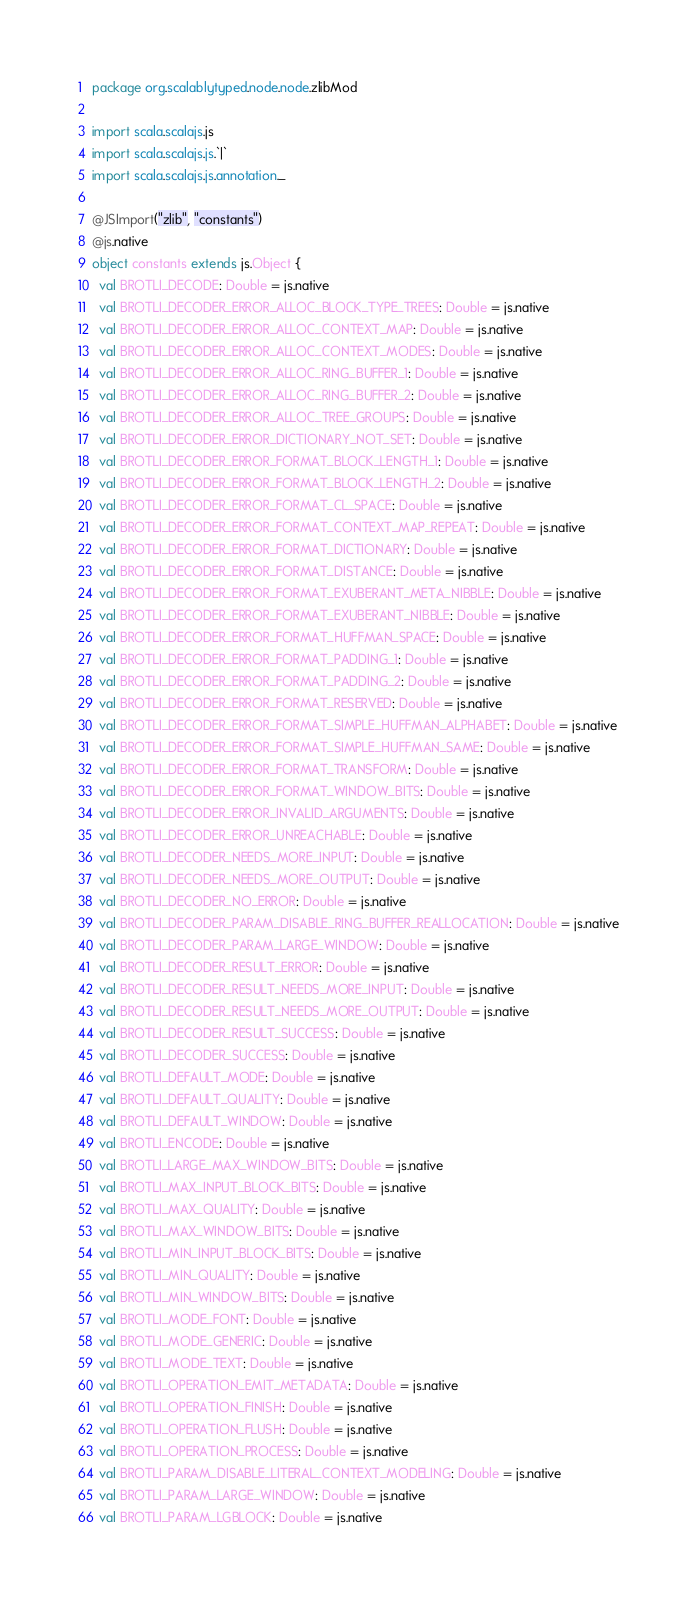Convert code to text. <code><loc_0><loc_0><loc_500><loc_500><_Scala_>package org.scalablytyped.node.node.zlibMod

import scala.scalajs.js
import scala.scalajs.js.`|`
import scala.scalajs.js.annotation._

@JSImport("zlib", "constants")
@js.native
object constants extends js.Object {
  val BROTLI_DECODE: Double = js.native
  val BROTLI_DECODER_ERROR_ALLOC_BLOCK_TYPE_TREES: Double = js.native
  val BROTLI_DECODER_ERROR_ALLOC_CONTEXT_MAP: Double = js.native
  val BROTLI_DECODER_ERROR_ALLOC_CONTEXT_MODES: Double = js.native
  val BROTLI_DECODER_ERROR_ALLOC_RING_BUFFER_1: Double = js.native
  val BROTLI_DECODER_ERROR_ALLOC_RING_BUFFER_2: Double = js.native
  val BROTLI_DECODER_ERROR_ALLOC_TREE_GROUPS: Double = js.native
  val BROTLI_DECODER_ERROR_DICTIONARY_NOT_SET: Double = js.native
  val BROTLI_DECODER_ERROR_FORMAT_BLOCK_LENGTH_1: Double = js.native
  val BROTLI_DECODER_ERROR_FORMAT_BLOCK_LENGTH_2: Double = js.native
  val BROTLI_DECODER_ERROR_FORMAT_CL_SPACE: Double = js.native
  val BROTLI_DECODER_ERROR_FORMAT_CONTEXT_MAP_REPEAT: Double = js.native
  val BROTLI_DECODER_ERROR_FORMAT_DICTIONARY: Double = js.native
  val BROTLI_DECODER_ERROR_FORMAT_DISTANCE: Double = js.native
  val BROTLI_DECODER_ERROR_FORMAT_EXUBERANT_META_NIBBLE: Double = js.native
  val BROTLI_DECODER_ERROR_FORMAT_EXUBERANT_NIBBLE: Double = js.native
  val BROTLI_DECODER_ERROR_FORMAT_HUFFMAN_SPACE: Double = js.native
  val BROTLI_DECODER_ERROR_FORMAT_PADDING_1: Double = js.native
  val BROTLI_DECODER_ERROR_FORMAT_PADDING_2: Double = js.native
  val BROTLI_DECODER_ERROR_FORMAT_RESERVED: Double = js.native
  val BROTLI_DECODER_ERROR_FORMAT_SIMPLE_HUFFMAN_ALPHABET: Double = js.native
  val BROTLI_DECODER_ERROR_FORMAT_SIMPLE_HUFFMAN_SAME: Double = js.native
  val BROTLI_DECODER_ERROR_FORMAT_TRANSFORM: Double = js.native
  val BROTLI_DECODER_ERROR_FORMAT_WINDOW_BITS: Double = js.native
  val BROTLI_DECODER_ERROR_INVALID_ARGUMENTS: Double = js.native
  val BROTLI_DECODER_ERROR_UNREACHABLE: Double = js.native
  val BROTLI_DECODER_NEEDS_MORE_INPUT: Double = js.native
  val BROTLI_DECODER_NEEDS_MORE_OUTPUT: Double = js.native
  val BROTLI_DECODER_NO_ERROR: Double = js.native
  val BROTLI_DECODER_PARAM_DISABLE_RING_BUFFER_REALLOCATION: Double = js.native
  val BROTLI_DECODER_PARAM_LARGE_WINDOW: Double = js.native
  val BROTLI_DECODER_RESULT_ERROR: Double = js.native
  val BROTLI_DECODER_RESULT_NEEDS_MORE_INPUT: Double = js.native
  val BROTLI_DECODER_RESULT_NEEDS_MORE_OUTPUT: Double = js.native
  val BROTLI_DECODER_RESULT_SUCCESS: Double = js.native
  val BROTLI_DECODER_SUCCESS: Double = js.native
  val BROTLI_DEFAULT_MODE: Double = js.native
  val BROTLI_DEFAULT_QUALITY: Double = js.native
  val BROTLI_DEFAULT_WINDOW: Double = js.native
  val BROTLI_ENCODE: Double = js.native
  val BROTLI_LARGE_MAX_WINDOW_BITS: Double = js.native
  val BROTLI_MAX_INPUT_BLOCK_BITS: Double = js.native
  val BROTLI_MAX_QUALITY: Double = js.native
  val BROTLI_MAX_WINDOW_BITS: Double = js.native
  val BROTLI_MIN_INPUT_BLOCK_BITS: Double = js.native
  val BROTLI_MIN_QUALITY: Double = js.native
  val BROTLI_MIN_WINDOW_BITS: Double = js.native
  val BROTLI_MODE_FONT: Double = js.native
  val BROTLI_MODE_GENERIC: Double = js.native
  val BROTLI_MODE_TEXT: Double = js.native
  val BROTLI_OPERATION_EMIT_METADATA: Double = js.native
  val BROTLI_OPERATION_FINISH: Double = js.native
  val BROTLI_OPERATION_FLUSH: Double = js.native
  val BROTLI_OPERATION_PROCESS: Double = js.native
  val BROTLI_PARAM_DISABLE_LITERAL_CONTEXT_MODELING: Double = js.native
  val BROTLI_PARAM_LARGE_WINDOW: Double = js.native
  val BROTLI_PARAM_LGBLOCK: Double = js.native</code> 